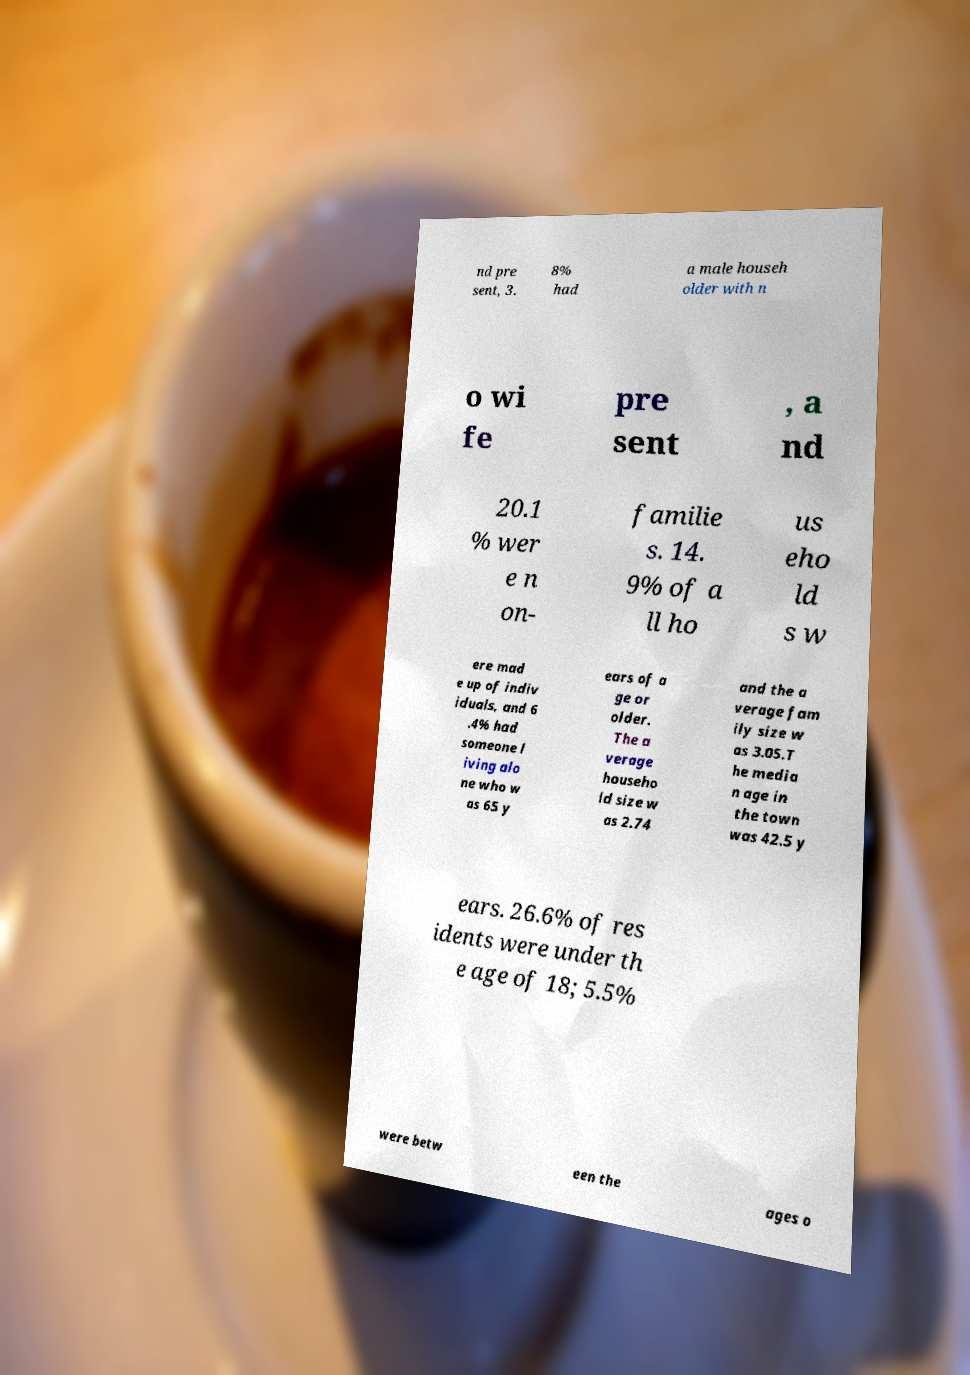There's text embedded in this image that I need extracted. Can you transcribe it verbatim? nd pre sent, 3. 8% had a male househ older with n o wi fe pre sent , a nd 20.1 % wer e n on- familie s. 14. 9% of a ll ho us eho ld s w ere mad e up of indiv iduals, and 6 .4% had someone l iving alo ne who w as 65 y ears of a ge or older. The a verage househo ld size w as 2.74 and the a verage fam ily size w as 3.05.T he media n age in the town was 42.5 y ears. 26.6% of res idents were under th e age of 18; 5.5% were betw een the ages o 